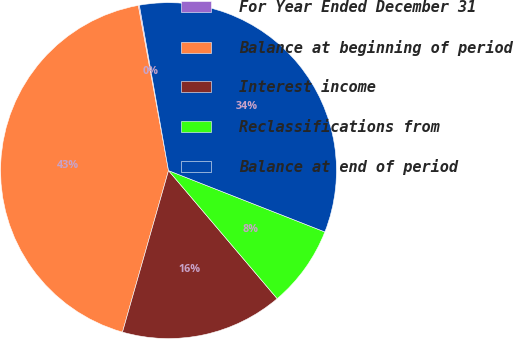Convert chart to OTSL. <chart><loc_0><loc_0><loc_500><loc_500><pie_chart><fcel>For Year Ended December 31<fcel>Balance at beginning of period<fcel>Interest income<fcel>Reclassifications from<fcel>Balance at end of period<nl><fcel>0.11%<fcel>42.7%<fcel>15.62%<fcel>7.85%<fcel>33.73%<nl></chart> 